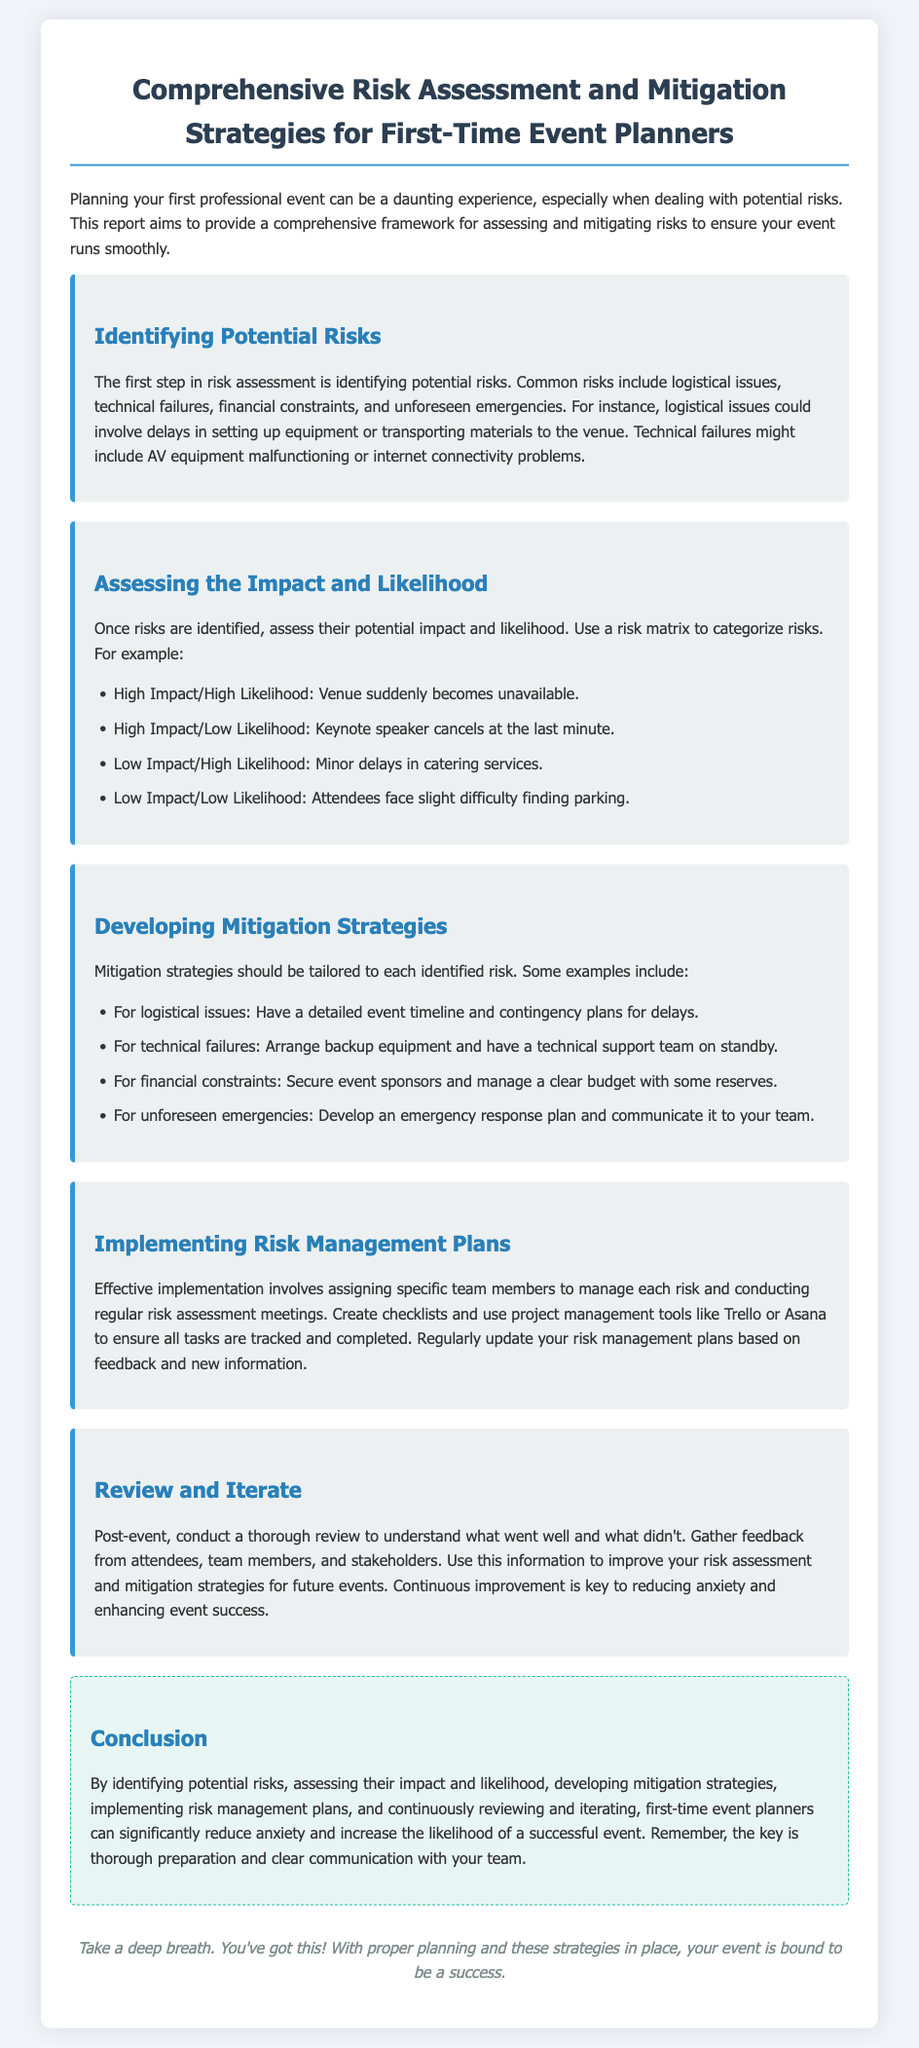What is the title of the report? The title of the report is explicitly stated at the beginning of the document.
Answer: Comprehensive Risk Assessment and Mitigation Strategies for First-Time Event Planners What is the first step in risk assessment? The document outlines the steps involved in risk assessment, indicating that identifying potential risks is the first step.
Answer: Identifying potential risks What type of issues could involve delays in setting up equipment? The report provides examples of logistical issues that can arise during event planning, noting delays in setting up.
Answer: Logistical issues What is a high impact/low likelihood risk mentioned in the document? The document categorizes risks and provides examples, one of which is the cancellation of a keynote speaker.
Answer: Keynote speaker cancels at the last minute What should be arranged to deal with technical failures? Mitigation strategies for technical issues are discussed, specifying that backup equipment should be arranged.
Answer: Backup equipment What project management tools are suggested for tracking tasks? The report mentions specific project management tools to aid in the task management process.
Answer: Trello or Asana What is essential for continuous improvement post-event? The conclusion emphasizes the importance of gathering feedback to enhance future efforts.
Answer: Feedback from attendees Who should be assigned to manage each risk? The document advises that specific team members should be responsible for each identified risk.
Answer: Specific team members What does the report suggest for unforeseen emergencies? The document provides strategies to deal with unforeseen emergencies, recommending the development of a response plan.
Answer: Emergency response plan 